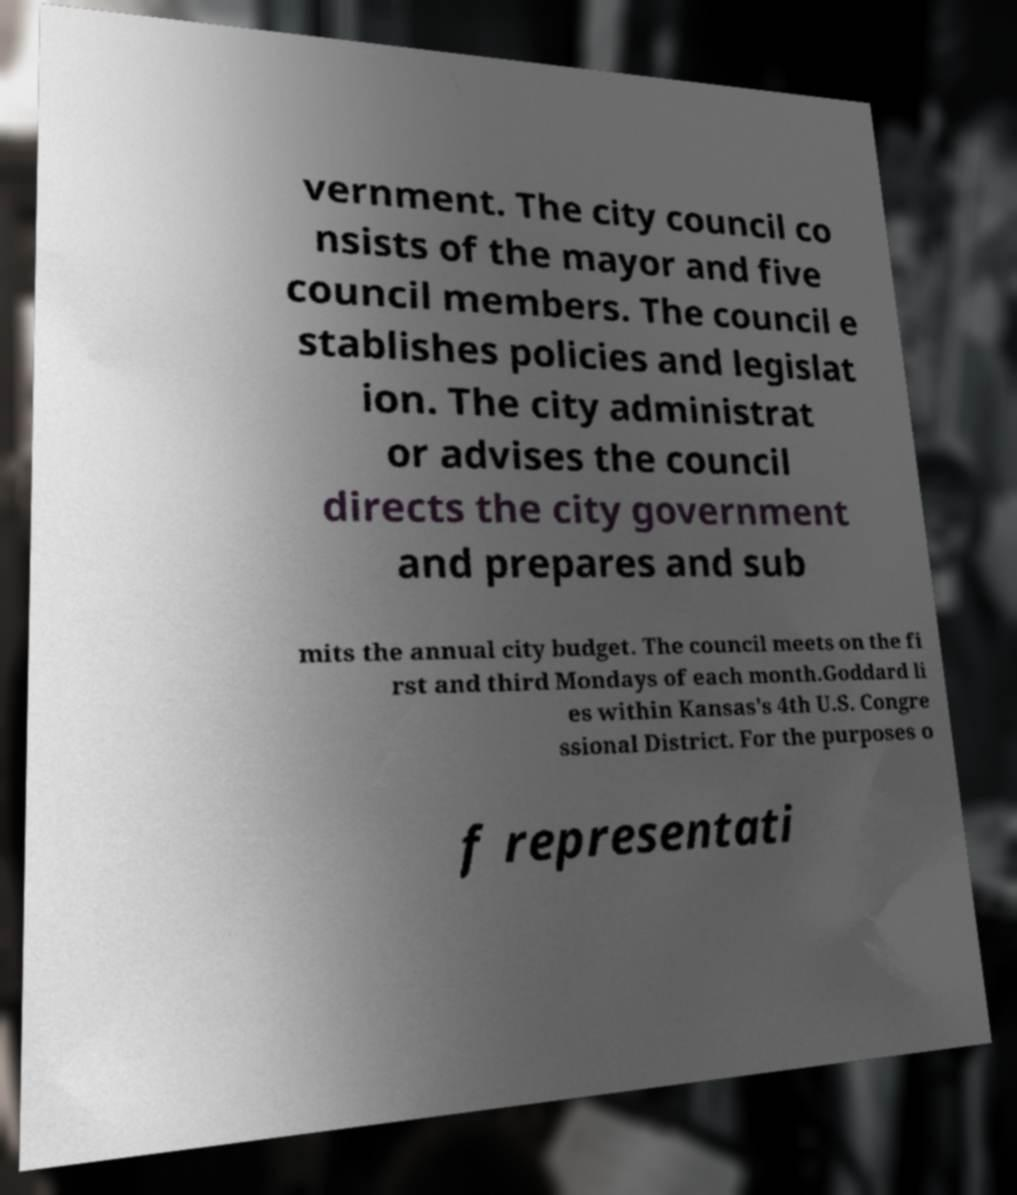Can you read and provide the text displayed in the image?This photo seems to have some interesting text. Can you extract and type it out for me? vernment. The city council co nsists of the mayor and five council members. The council e stablishes policies and legislat ion. The city administrat or advises the council directs the city government and prepares and sub mits the annual city budget. The council meets on the fi rst and third Mondays of each month.Goddard li es within Kansas's 4th U.S. Congre ssional District. For the purposes o f representati 